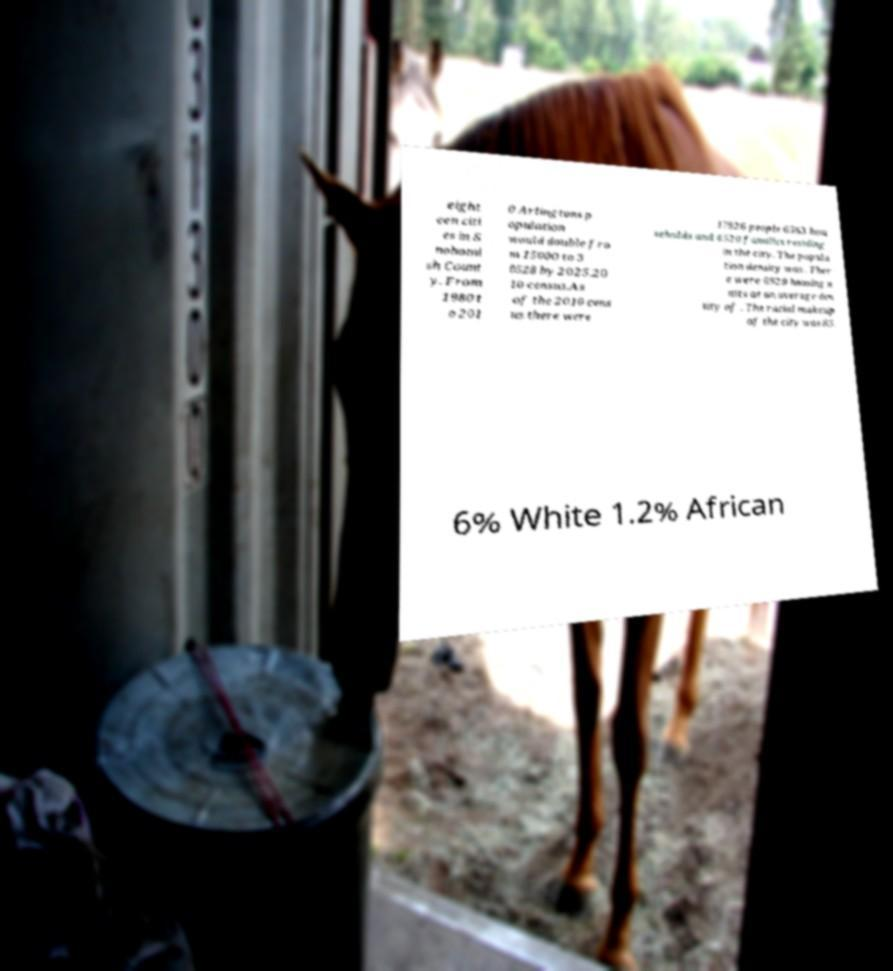Could you assist in decoding the text presented in this image and type it out clearly? eight een citi es in S nohomi sh Count y. From 1980 t o 201 0 Arlingtons p opulation would double fro m 15000 to 3 0528 by 2025.20 10 census.As of the 2010 cens us there were 17926 people 6563 hou seholds and 4520 families residing in the city. The popula tion density was . Ther e were 6929 housing u nits at an average den sity of . The racial makeup of the city was 85. 6% White 1.2% African 